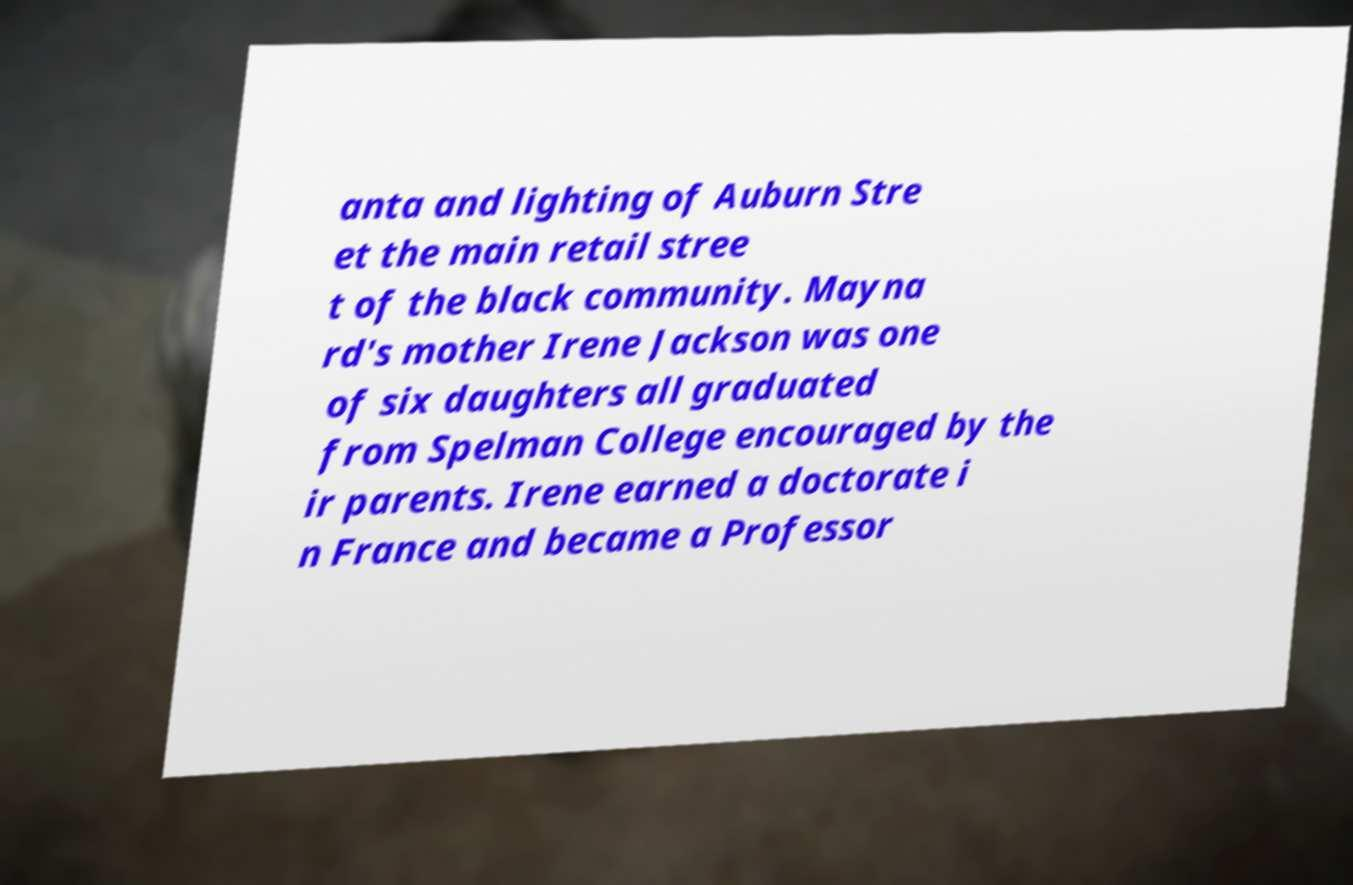Could you assist in decoding the text presented in this image and type it out clearly? anta and lighting of Auburn Stre et the main retail stree t of the black community. Mayna rd's mother Irene Jackson was one of six daughters all graduated from Spelman College encouraged by the ir parents. Irene earned a doctorate i n France and became a Professor 